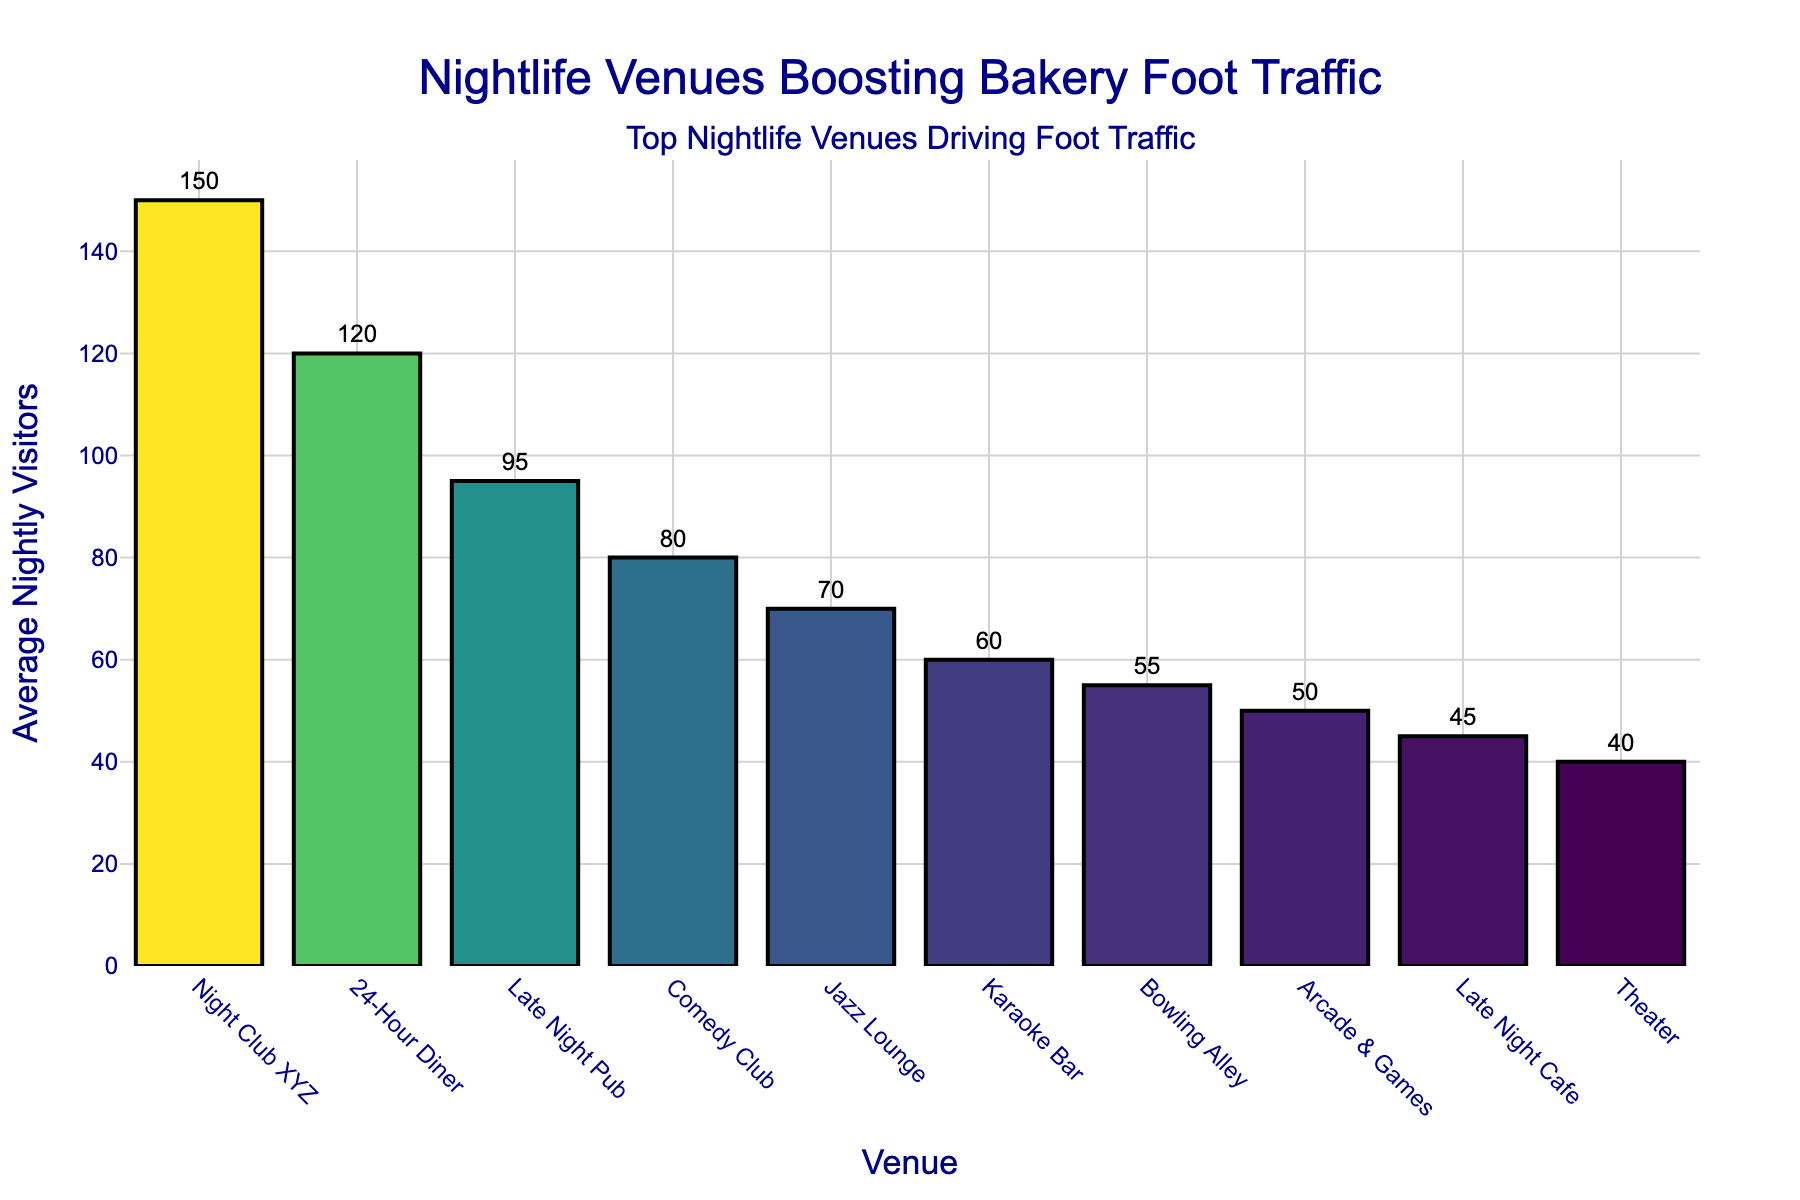What are the top three nightlife venues driving the most foot traffic to the bakery? The top three venues have the highest bars when observing the bar chart. They are listed from highest to lowest.
Answer: Night Club XYZ, 24-Hour Diner, Late Night Pub What is the difference in average nightly visitors between the Night Club XYZ and the Jazz Lounge? Subtract the average nightly visitors of Jazz Lounge (70) from Night Club XYZ (150): 150 - 70 = 80
Answer: 80 How many average nightly visitors are driven to the bakery by the Comedy Club and Jazz Lounge combined? Add the average nightly visitors of Comedy Club (80) and Jazz Lounge (70): 80 + 70 = 150
Answer: 150 Which venue, the 24-Hour Diner or the Bowling Alley, drives more foot traffic? Compare the average nightly visitors of 24-Hour Diner (120) to Bowling Alley (55). The 24-Hour Diner has more.
Answer: 24-Hour Diner What is the total average nightly visitor count from the top 5 nightlife venues? Add the visitors from the top 5 venues: Night Club XYZ (150) + 24-Hour Diner (120) + Late Night Pub (95) + Comedy Club (80) + Jazz Lounge (70): 150 + 120 + 95 + 80 + 70 = 515
Answer: 515 Which venue bar is colored the darkest in the figure? The venue with the highest number of visitors has the darkest color, which is Night Club XYZ.
Answer: Night Club XYZ Is the height of the Arcade & Games bar closer to the height of the Karaoke Bar or the Late Night Cafe bar? The height of the Arcade & Games (50) is closer to Karaoke Bar (60) than to Late Night Cafe (45), as the difference is smaller: 60 - 50 = 10 vs 50 - 45 = 5
Answer: Late Night Cafe What is the average number of nightly visitors for the bottom 2 venues? Add the average nightly visitors of the Karaoke Bar (60) and the Bowling Alley (55) and divide the sum by 2: (60 + 55) / 2 = 115 / 2 = 57.5
Answer: 57.5 Compare the foot traffic of the Theater and the Late Night Cafe. Which one has fewer visitors? The Theater has fewer visitors, with 40 compared to Late Night Cafe's 45.
Answer: Theater 